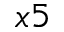<formula> <loc_0><loc_0><loc_500><loc_500>_ { x 5 }</formula> 